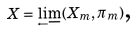<formula> <loc_0><loc_0><loc_500><loc_500>X = \lim _ { \longleftarrow } ( X _ { m } , \pi _ { m } ) \text {,}</formula> 